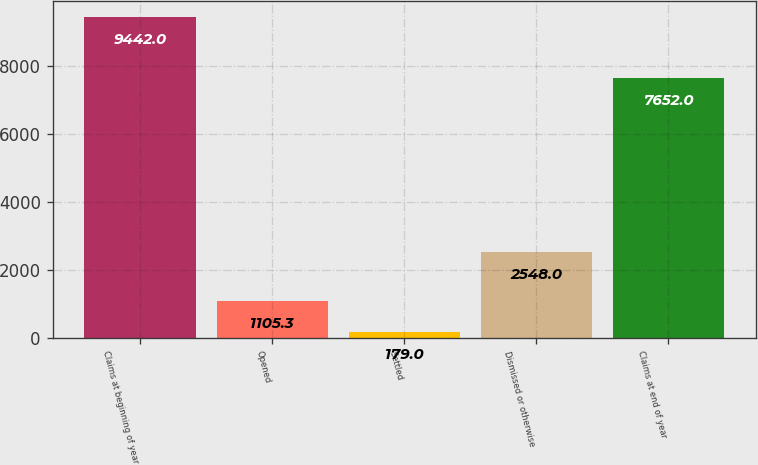Convert chart to OTSL. <chart><loc_0><loc_0><loc_500><loc_500><bar_chart><fcel>Claims at beginning of year<fcel>Opened<fcel>Settled<fcel>Dismissed or otherwise<fcel>Claims at end of year<nl><fcel>9442<fcel>1105.3<fcel>179<fcel>2548<fcel>7652<nl></chart> 